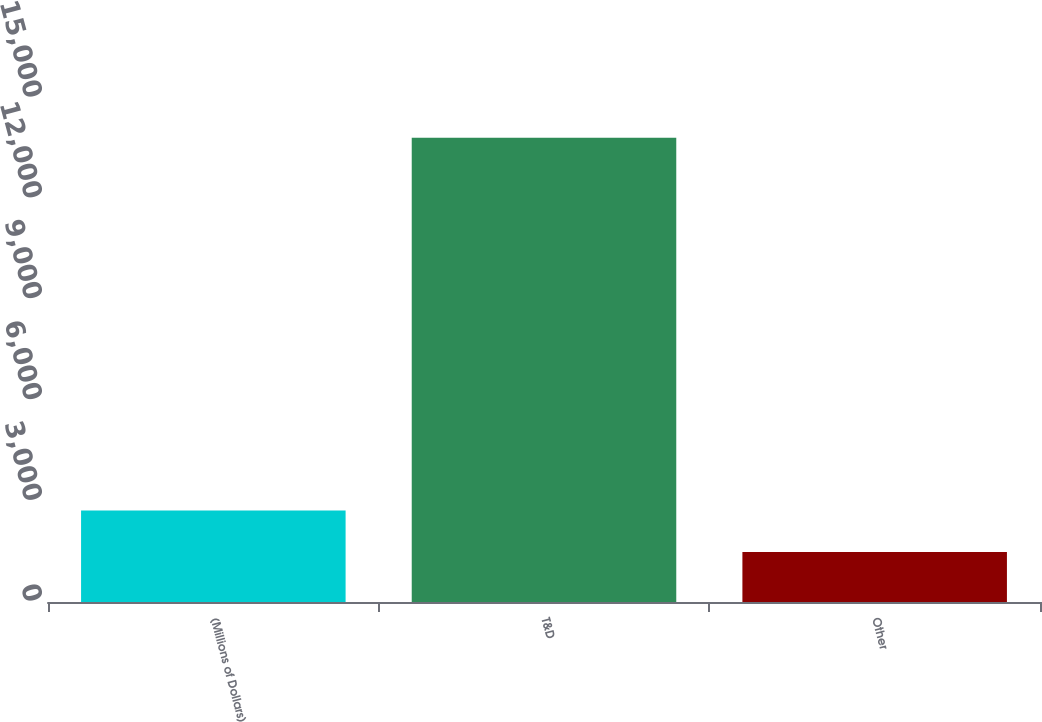Convert chart. <chart><loc_0><loc_0><loc_500><loc_500><bar_chart><fcel>(Millions of Dollars)<fcel>T&D<fcel>Other<nl><fcel>2720.1<fcel>13818<fcel>1487<nl></chart> 